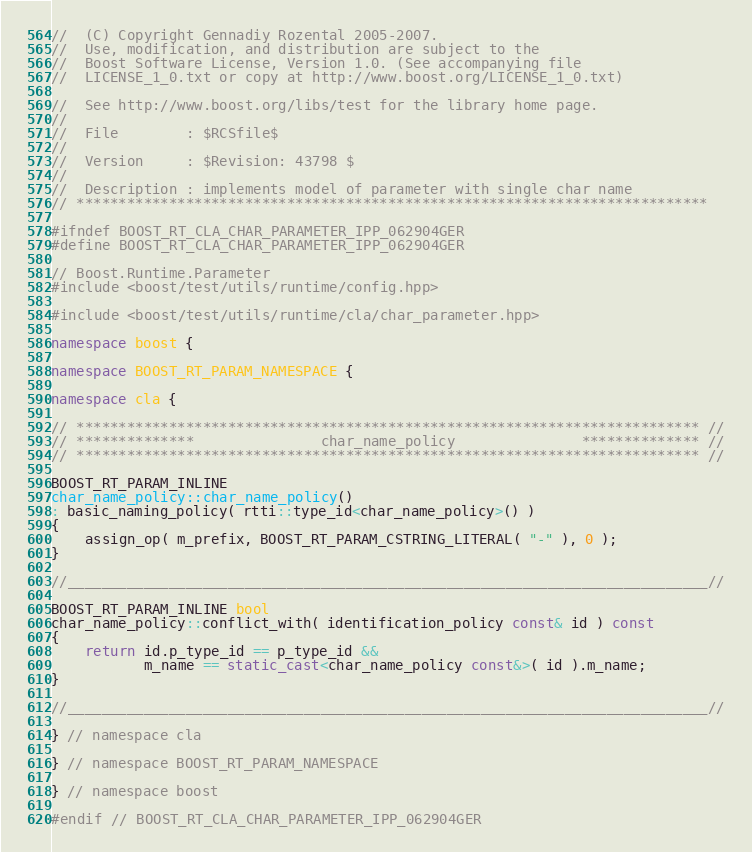<code> <loc_0><loc_0><loc_500><loc_500><_C++_>//  (C) Copyright Gennadiy Rozental 2005-2007.
//  Use, modification, and distribution are subject to the 
//  Boost Software License, Version 1.0. (See accompanying file 
//  LICENSE_1_0.txt or copy at http://www.boost.org/LICENSE_1_0.txt)

//  See http://www.boost.org/libs/test for the library home page.
//
//  File        : $RCSfile$
//
//  Version     : $Revision: 43798 $
//
//  Description : implements model of parameter with single char name
// ***************************************************************************

#ifndef BOOST_RT_CLA_CHAR_PARAMETER_IPP_062904GER
#define BOOST_RT_CLA_CHAR_PARAMETER_IPP_062904GER

// Boost.Runtime.Parameter
#include <boost/test/utils/runtime/config.hpp>

#include <boost/test/utils/runtime/cla/char_parameter.hpp>

namespace boost {

namespace BOOST_RT_PARAM_NAMESPACE {

namespace cla {

// ************************************************************************** //
// **************               char_name_policy               ************** //
// ************************************************************************** //

BOOST_RT_PARAM_INLINE 
char_name_policy::char_name_policy()
: basic_naming_policy( rtti::type_id<char_name_policy>() )
{
    assign_op( m_prefix, BOOST_RT_PARAM_CSTRING_LITERAL( "-" ), 0 );
}

//____________________________________________________________________________//

BOOST_RT_PARAM_INLINE bool
char_name_policy::conflict_with( identification_policy const& id ) const
{
    return id.p_type_id == p_type_id && 
           m_name == static_cast<char_name_policy const&>( id ).m_name;
}

//____________________________________________________________________________//

} // namespace cla

} // namespace BOOST_RT_PARAM_NAMESPACE

} // namespace boost

#endif // BOOST_RT_CLA_CHAR_PARAMETER_IPP_062904GER
</code> 